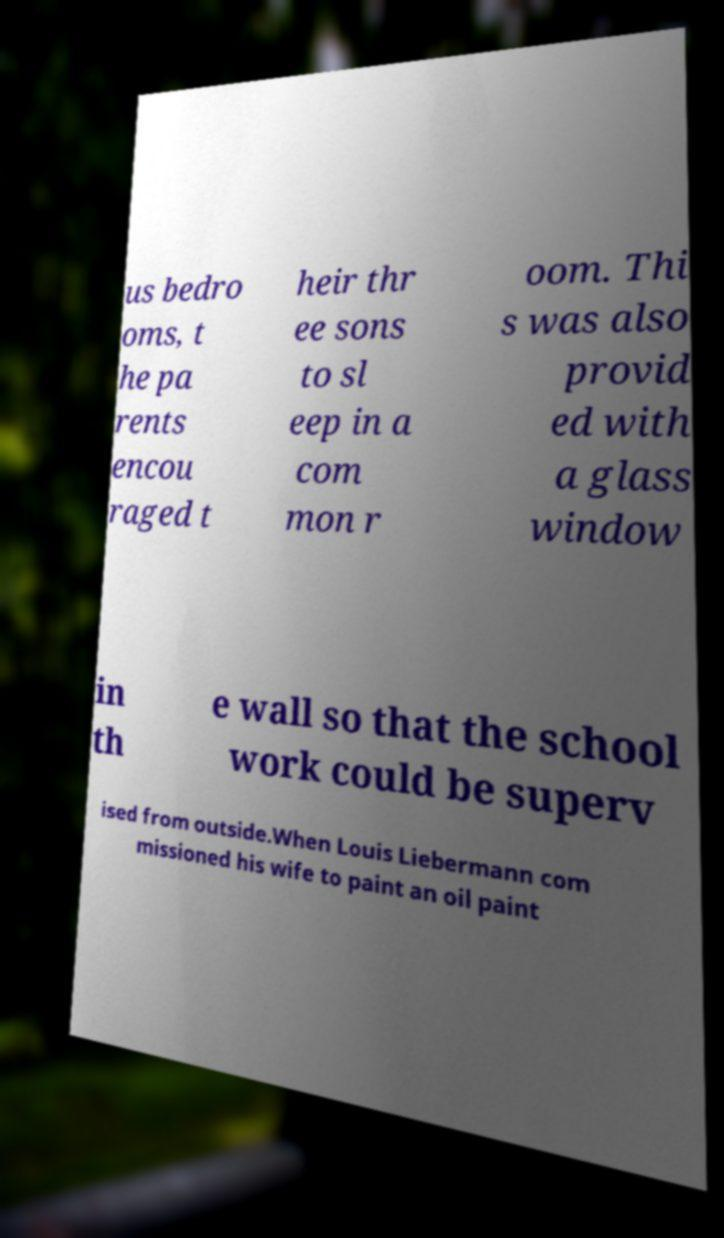For documentation purposes, I need the text within this image transcribed. Could you provide that? us bedro oms, t he pa rents encou raged t heir thr ee sons to sl eep in a com mon r oom. Thi s was also provid ed with a glass window in th e wall so that the school work could be superv ised from outside.When Louis Liebermann com missioned his wife to paint an oil paint 